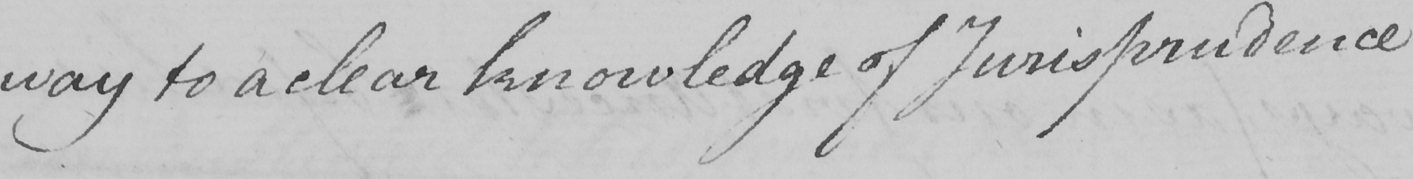What is written in this line of handwriting? way to a clear knowledge of Jurisprudence 